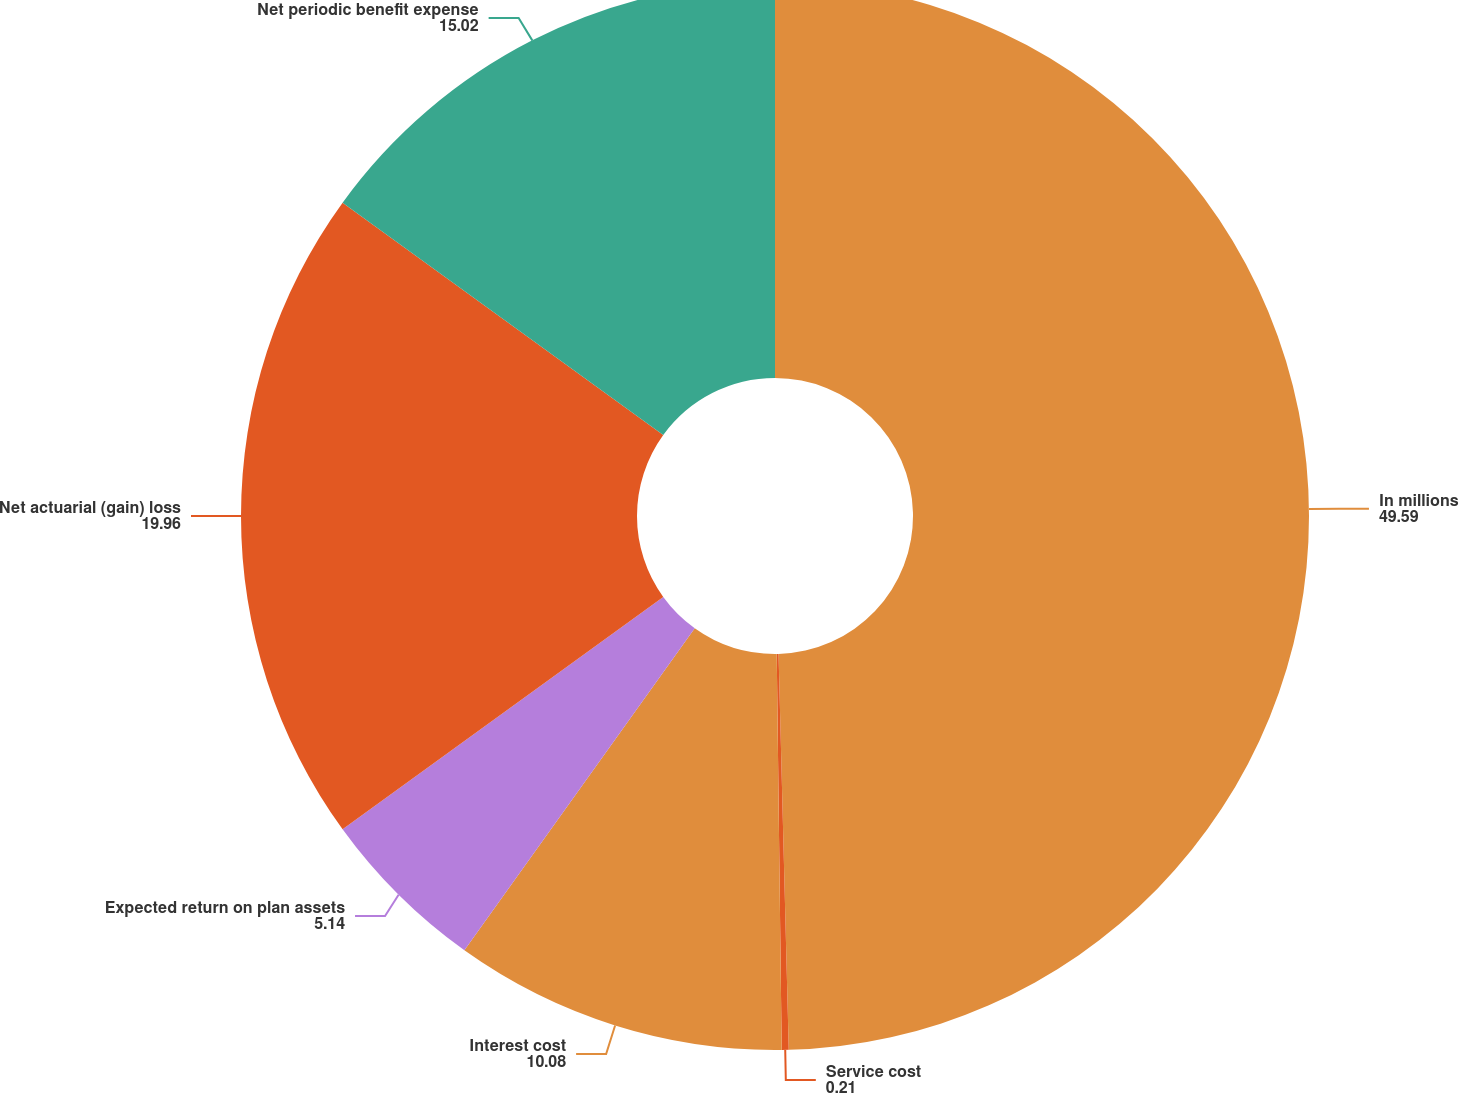Convert chart to OTSL. <chart><loc_0><loc_0><loc_500><loc_500><pie_chart><fcel>In millions<fcel>Service cost<fcel>Interest cost<fcel>Expected return on plan assets<fcel>Net actuarial (gain) loss<fcel>Net periodic benefit expense<nl><fcel>49.59%<fcel>0.21%<fcel>10.08%<fcel>5.14%<fcel>19.96%<fcel>15.02%<nl></chart> 